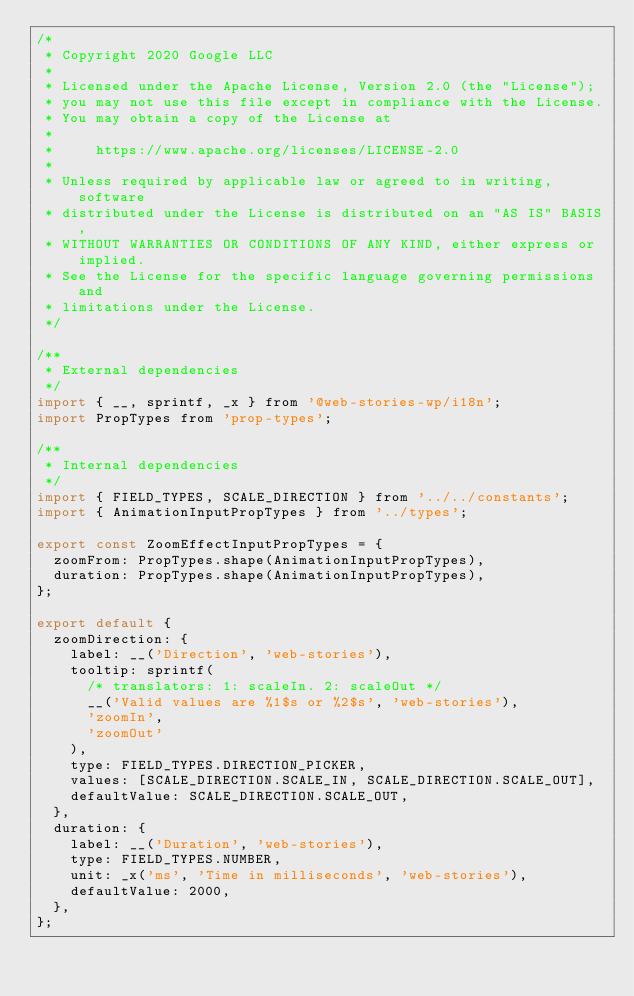Convert code to text. <code><loc_0><loc_0><loc_500><loc_500><_JavaScript_>/*
 * Copyright 2020 Google LLC
 *
 * Licensed under the Apache License, Version 2.0 (the "License");
 * you may not use this file except in compliance with the License.
 * You may obtain a copy of the License at
 *
 *     https://www.apache.org/licenses/LICENSE-2.0
 *
 * Unless required by applicable law or agreed to in writing, software
 * distributed under the License is distributed on an "AS IS" BASIS,
 * WITHOUT WARRANTIES OR CONDITIONS OF ANY KIND, either express or implied.
 * See the License for the specific language governing permissions and
 * limitations under the License.
 */

/**
 * External dependencies
 */
import { __, sprintf, _x } from '@web-stories-wp/i18n';
import PropTypes from 'prop-types';

/**
 * Internal dependencies
 */
import { FIELD_TYPES, SCALE_DIRECTION } from '../../constants';
import { AnimationInputPropTypes } from '../types';

export const ZoomEffectInputPropTypes = {
  zoomFrom: PropTypes.shape(AnimationInputPropTypes),
  duration: PropTypes.shape(AnimationInputPropTypes),
};

export default {
  zoomDirection: {
    label: __('Direction', 'web-stories'),
    tooltip: sprintf(
      /* translators: 1: scaleIn. 2: scaleOut */
      __('Valid values are %1$s or %2$s', 'web-stories'),
      'zoomIn',
      'zoomOut'
    ),
    type: FIELD_TYPES.DIRECTION_PICKER,
    values: [SCALE_DIRECTION.SCALE_IN, SCALE_DIRECTION.SCALE_OUT],
    defaultValue: SCALE_DIRECTION.SCALE_OUT,
  },
  duration: {
    label: __('Duration', 'web-stories'),
    type: FIELD_TYPES.NUMBER,
    unit: _x('ms', 'Time in milliseconds', 'web-stories'),
    defaultValue: 2000,
  },
};
</code> 